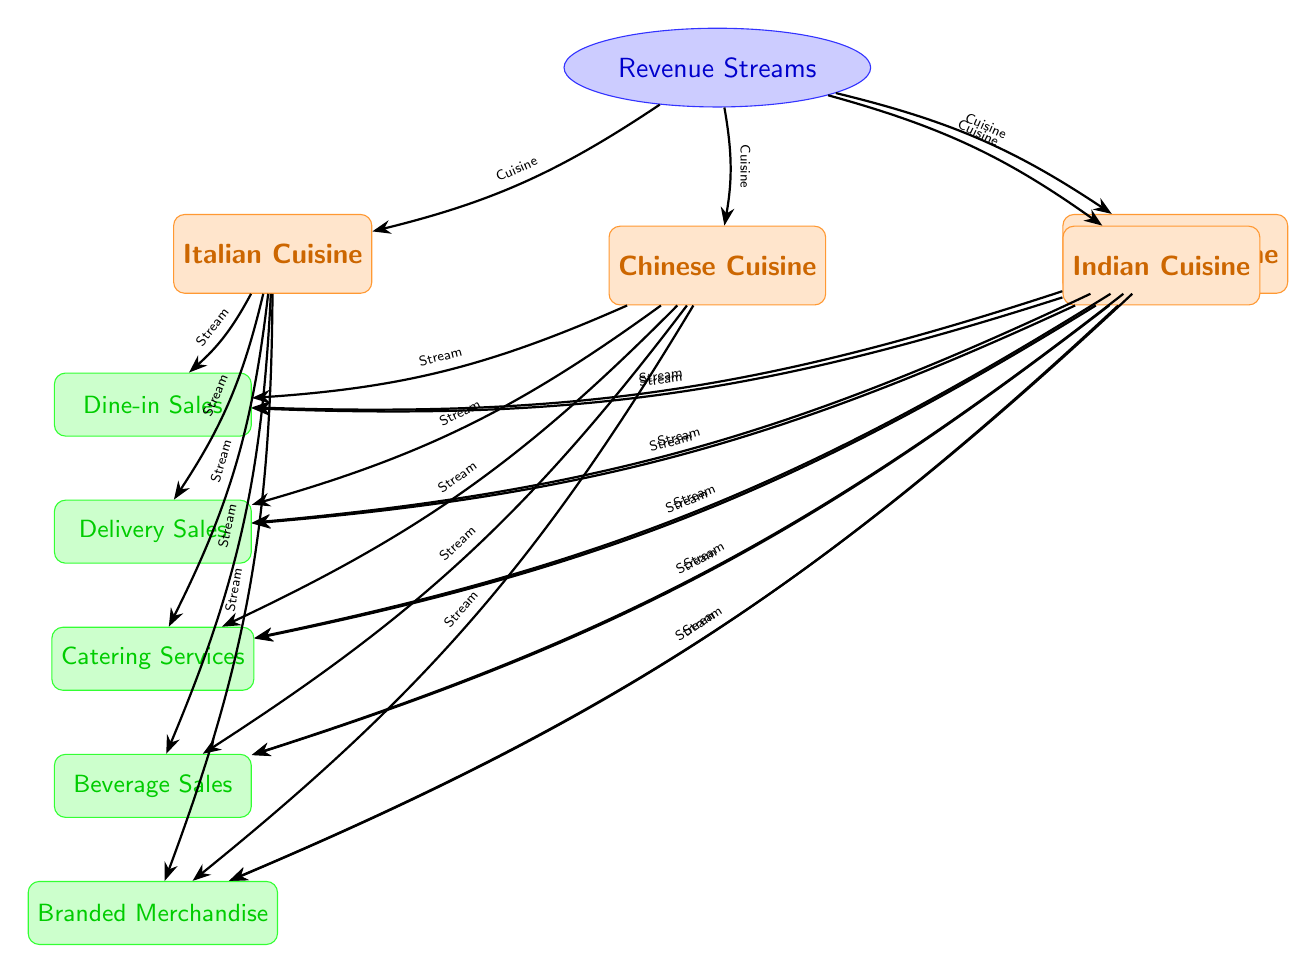What are the cuisines represented in the diagram? The diagram includes four cuisines: Italian Cuisine, Chinese Cuisine, Mexican Cuisine, and Indian Cuisine. These cuisines are listed as nodes connected to the main revenue streams node.
Answer: Italian Cuisine, Chinese Cuisine, Mexican Cuisine, Indian Cuisine How many revenue streams are listed in connection with each cuisine? The diagram shows five revenue streams: Dine-in Sales, Delivery Sales, Catering Services, Beverage Sales, and Branded Merchandise. Each cuisine is connected to these five streams, indicating they share the same sources of revenue.
Answer: Five Which revenue stream directly follows Delivery Sales? In the diagram, Delivery Sales is followed directly by Catering Services. This relationship illustrates the sequence of revenue streams associated with each cuisine.
Answer: Catering Services What type of relationship is shown between cuisines and revenue streams? The relationship between cuisines and revenue streams is a one-to-many relationship. Each cuisine connects to multiple revenue streams, indicating that one cuisine can generate revenue from several channels.
Answer: One-to-many Which two cuisines have the same type of revenue streams? All four cuisines—Italian, Chinese, Mexican, and Indian—share the same types of revenue streams: Dine-in Sales, Delivery Sales, Catering Services, Beverage Sales, and Branded Merchandise. Thus, they all have identical categories of revenue generation.
Answer: All cuisines How many total nodes are there in the diagram? The diagram contains a total of nine nodes: one main revenue streams node, four cuisine nodes, and five revenue stream nodes. This includes all types of nodes contributing to the visual framework of the food chain diagram.
Answer: Nine Which revenue stream is furthest away from the main revenue node? Branded Merchandise is furthest away from the main revenue streams node. It is the last revenue stream in the hierarchy depicted for each cuisine, indicating it is the least direct source of revenue.
Answer: Branded Merchandise What color represents the revenue stream nodes in the diagram? The revenue stream nodes in the diagram are represented by blue, specifically in shades of blue for both the outlines and fill of the nodes. This helps visually distinguish them from the cuisine nodes.
Answer: Blue 